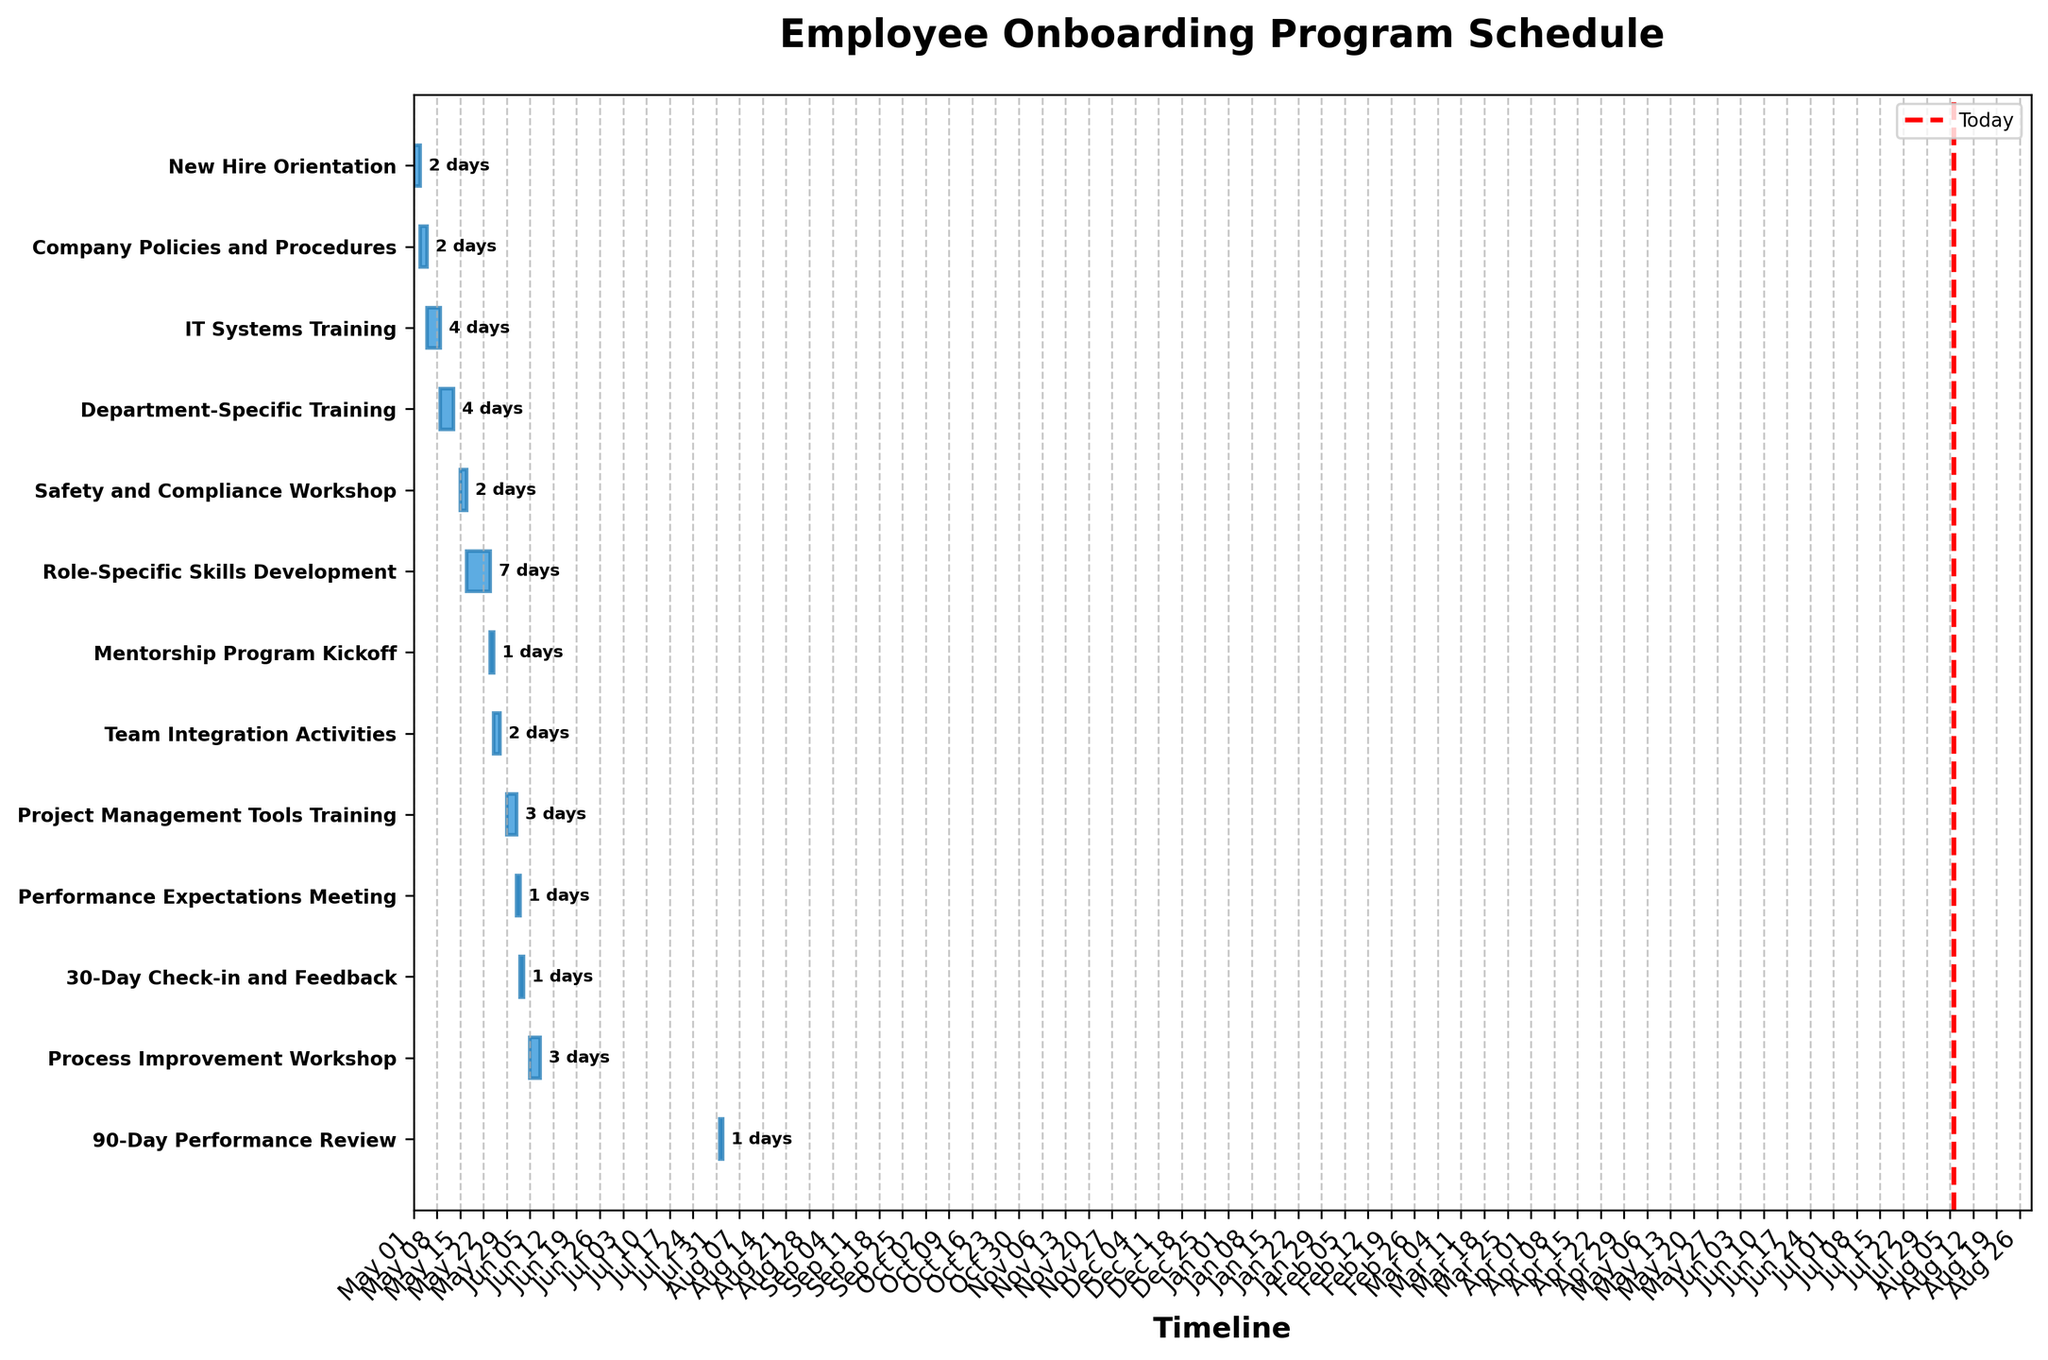What's the title of the Gantt Chart? The title is visibly located at the top of the plot, generally in a larger and bolder font to grab attention.
Answer: Employee Onboarding Program Schedule What is the total duration of the IT Systems Training? Locate the "IT Systems Training" task on the vertical axis and check the length of the horizontal bar corresponding to it. The plot also has annotations indicating the duration in days.
Answer: 4 days How many tasks are part of the onboarding program? Count the number of horizontal bars in the Gantt Chart, each representing a separate task.
Answer: 13 tasks Between which dates does the Department-Specific Training occur? Identify the "Department-Specific Training" task on the vertical axis and see the start and end points of the corresponding horizontal bar.
Answer: May 9, 2023 - May 12, 2023 Which task has the longest duration, and how long is it? Find the horizontal bar with the longest length. The plot's annotations indicating duration can help identify this quickly.
Answer: Role-Specific Skills Development, 7 days What is the sequence of tasks after IT Systems Training? Locate the "IT Systems Training" on the vertical axis and observe the tasks listed immediately below it.
Answer: Department-Specific Training, Safety and Compliance Workshop Is there a task scheduled for the current date? Observe the vertical red line marked "Today" and see if it intersects any task's horizontal bar.
Answer: Not answerable; depends on the current date Compare the duration of Company Policies and Procedures and Safety and Compliance Workshop. Which is longer? Locate both "Company Policies and Procedures" and "Safety and Compliance Workshop" on the vertical axis and compare the length of their corresponding horizontal bars.
Answer: Both are 2 days long How many tasks are scheduled after the 30-Day Check-in and Feedback? Locate the "30-Day Check-in and Feedback" task and count the tasks listed below it.
Answer: 3 tasks What is the duration of the Project Management Tools Training, and when does it start? Find the "Project Management Tools Training" task and check its horizontal bar for duration and start date.
Answer: 3 days, starts on May 29, 2023 